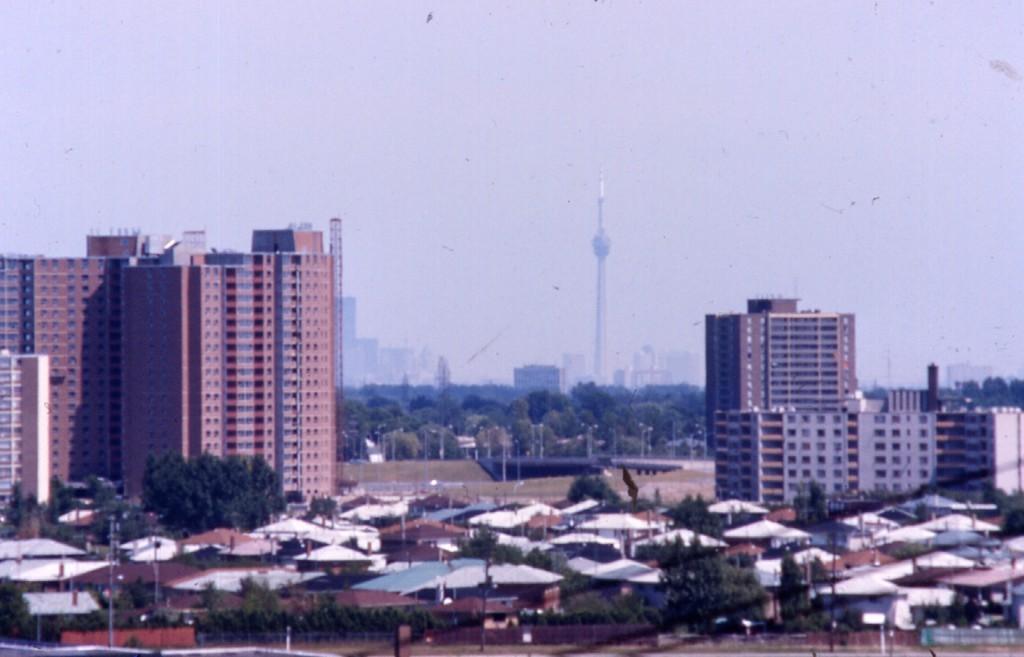Describe this image in one or two sentences. In the center of the image there are houses,buildings. In the background of there are trees. There is a tower. At the top of the image there is sky. 